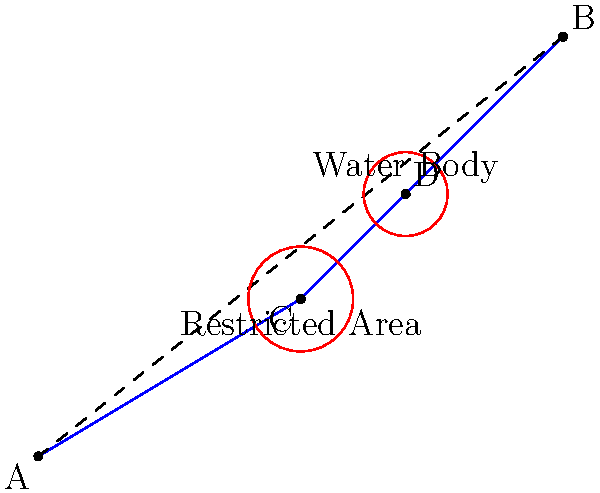In a protected area, you need to determine the shortest path from point A to point B while avoiding a restricted area centered at point C and a water body centered at point D. Given that the straight-line distance from A to B is 12.8 km, and the path A-C-D-B avoids both obstacles, what is the additional distance traveled compared to the straight path? To solve this problem, we need to follow these steps:

1) First, calculate the length of the path A-C-D-B:
   
   AC = $\sqrt{5^2 + 3^2} = \sqrt{34}$ km
   CD = $\sqrt{2^2 + 2^2} = 2\sqrt{2}$ km
   DB = $\sqrt{3^2 + 3^2} = 3\sqrt{2}$ km

   Total length = $\sqrt{34} + 2\sqrt{2} + 3\sqrt{2} = \sqrt{34} + 5\sqrt{2}$ km

2) Convert this to a decimal:
   $\sqrt{34} \approx 5.83$ km
   $5\sqrt{2} \approx 7.07$ km
   
   Total length ≈ 5.83 + 7.07 = 12.90 km

3) Calculate the difference between this path and the straight path:
   12.90 km - 12.8 km = 0.10 km

4) Convert to meters:
   0.10 km × 1000 = 100 meters

Therefore, the additional distance traveled is approximately 100 meters.
Answer: 100 meters 